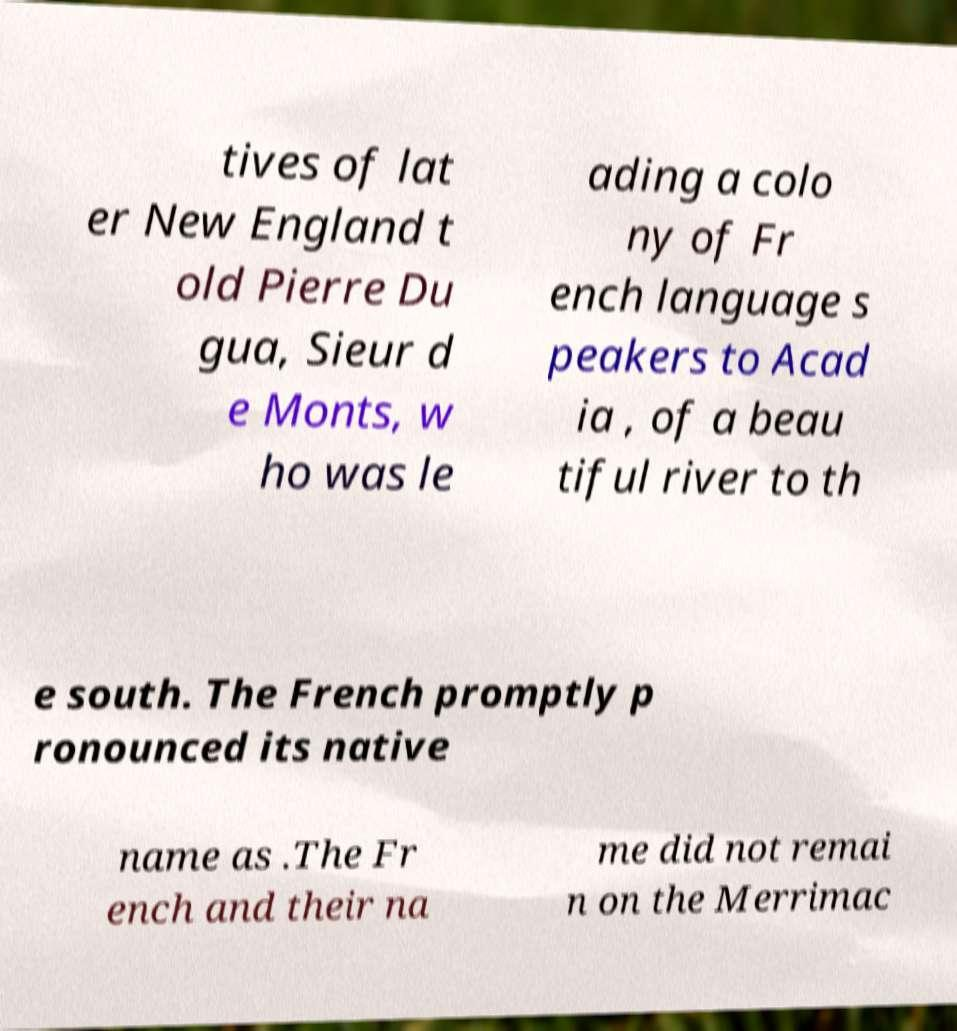Can you accurately transcribe the text from the provided image for me? tives of lat er New England t old Pierre Du gua, Sieur d e Monts, w ho was le ading a colo ny of Fr ench language s peakers to Acad ia , of a beau tiful river to th e south. The French promptly p ronounced its native name as .The Fr ench and their na me did not remai n on the Merrimac 